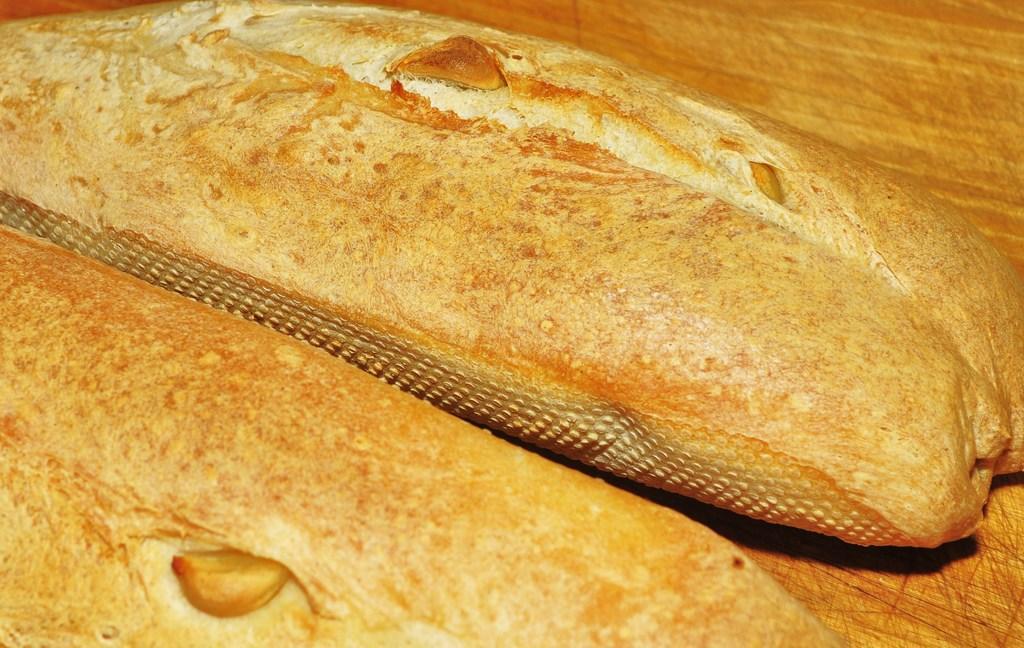In one or two sentences, can you explain what this image depicts? In this picture we can observe two sourdoughs placed on the table. These are in cream color. 